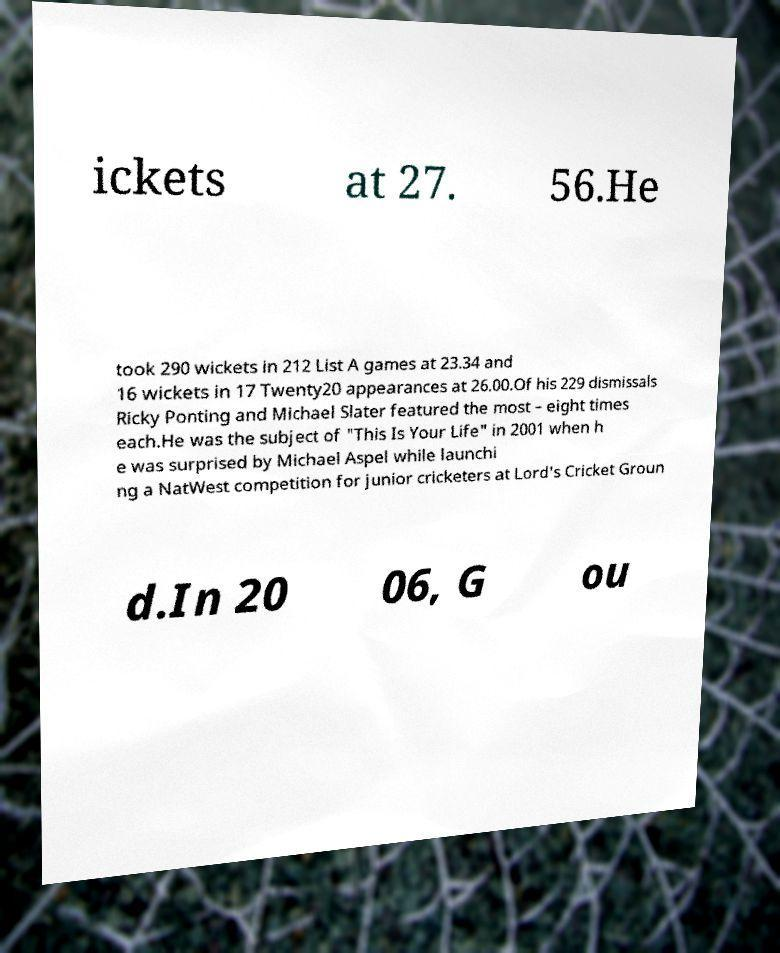Can you accurately transcribe the text from the provided image for me? ickets at 27. 56.He took 290 wickets in 212 List A games at 23.34 and 16 wickets in 17 Twenty20 appearances at 26.00.Of his 229 dismissals Ricky Ponting and Michael Slater featured the most – eight times each.He was the subject of "This Is Your Life" in 2001 when h e was surprised by Michael Aspel while launchi ng a NatWest competition for junior cricketers at Lord's Cricket Groun d.In 20 06, G ou 